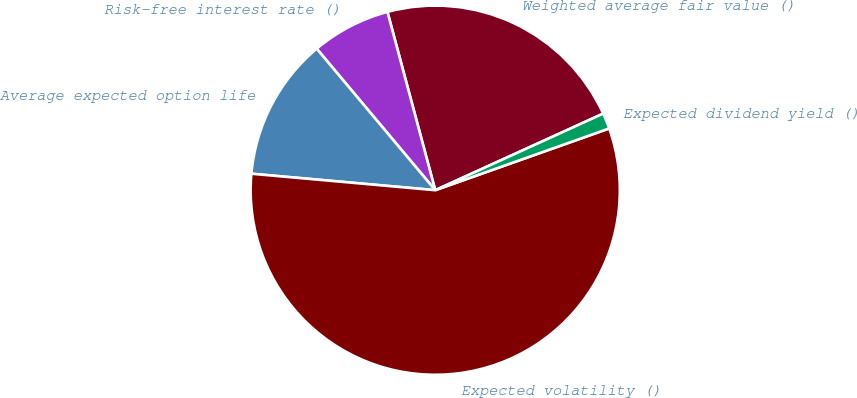<chart> <loc_0><loc_0><loc_500><loc_500><pie_chart><fcel>Weighted average fair value ()<fcel>Risk-free interest rate ()<fcel>Average expected option life<fcel>Expected volatility ()<fcel>Expected dividend yield ()<nl><fcel>22.36%<fcel>6.93%<fcel>12.48%<fcel>56.85%<fcel>1.38%<nl></chart> 